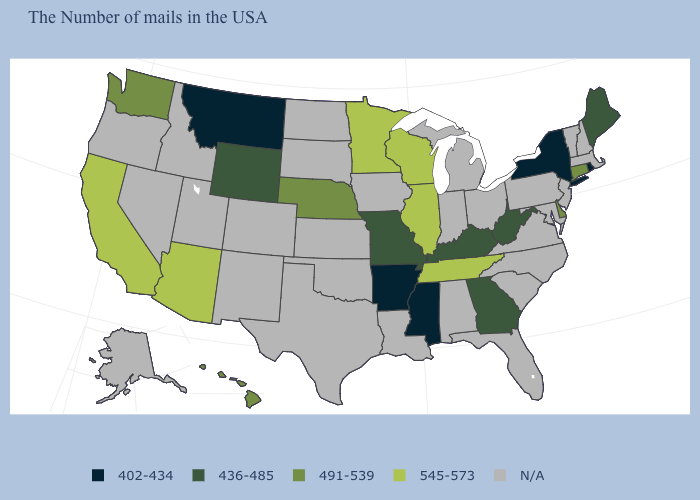What is the value of Connecticut?
Write a very short answer. 491-539. Does Missouri have the lowest value in the MidWest?
Quick response, please. Yes. Name the states that have a value in the range 436-485?
Quick response, please. Maine, West Virginia, Georgia, Kentucky, Missouri, Wyoming. What is the value of Iowa?
Write a very short answer. N/A. What is the value of Utah?
Short answer required. N/A. Name the states that have a value in the range 491-539?
Short answer required. Connecticut, Delaware, Nebraska, Washington, Hawaii. Name the states that have a value in the range 545-573?
Concise answer only. Tennessee, Wisconsin, Illinois, Minnesota, Arizona, California. What is the value of New York?
Keep it brief. 402-434. Among the states that border Pennsylvania , does New York have the lowest value?
Keep it brief. Yes. Does Minnesota have the highest value in the USA?
Concise answer only. Yes. What is the highest value in the USA?
Short answer required. 545-573. Among the states that border North Dakota , which have the lowest value?
Be succinct. Montana. Which states have the lowest value in the South?
Give a very brief answer. Mississippi, Arkansas. What is the value of Rhode Island?
Be succinct. 402-434. 